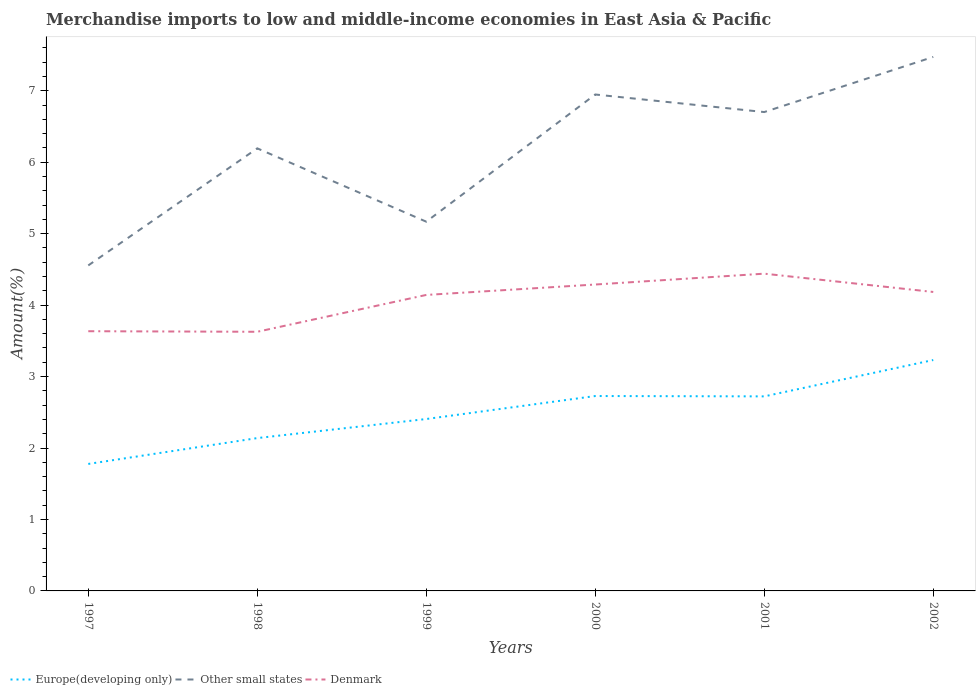How many different coloured lines are there?
Offer a very short reply. 3. Is the number of lines equal to the number of legend labels?
Ensure brevity in your answer.  Yes. Across all years, what is the maximum percentage of amount earned from merchandise imports in Europe(developing only)?
Your answer should be compact. 1.78. What is the total percentage of amount earned from merchandise imports in Europe(developing only) in the graph?
Your answer should be compact. -0.5. What is the difference between the highest and the second highest percentage of amount earned from merchandise imports in Europe(developing only)?
Make the answer very short. 1.45. Is the percentage of amount earned from merchandise imports in Europe(developing only) strictly greater than the percentage of amount earned from merchandise imports in Other small states over the years?
Give a very brief answer. Yes. How many lines are there?
Offer a very short reply. 3. How many years are there in the graph?
Provide a short and direct response. 6. Where does the legend appear in the graph?
Give a very brief answer. Bottom left. How are the legend labels stacked?
Provide a succinct answer. Horizontal. What is the title of the graph?
Offer a terse response. Merchandise imports to low and middle-income economies in East Asia & Pacific. Does "Macao" appear as one of the legend labels in the graph?
Keep it short and to the point. No. What is the label or title of the X-axis?
Your answer should be compact. Years. What is the label or title of the Y-axis?
Your answer should be very brief. Amount(%). What is the Amount(%) of Europe(developing only) in 1997?
Make the answer very short. 1.78. What is the Amount(%) of Other small states in 1997?
Your response must be concise. 4.56. What is the Amount(%) of Denmark in 1997?
Provide a succinct answer. 3.63. What is the Amount(%) in Europe(developing only) in 1998?
Provide a short and direct response. 2.14. What is the Amount(%) in Other small states in 1998?
Ensure brevity in your answer.  6.19. What is the Amount(%) of Denmark in 1998?
Keep it short and to the point. 3.63. What is the Amount(%) in Europe(developing only) in 1999?
Keep it short and to the point. 2.41. What is the Amount(%) in Other small states in 1999?
Keep it short and to the point. 5.17. What is the Amount(%) in Denmark in 1999?
Give a very brief answer. 4.14. What is the Amount(%) in Europe(developing only) in 2000?
Offer a very short reply. 2.73. What is the Amount(%) of Other small states in 2000?
Your response must be concise. 6.95. What is the Amount(%) in Denmark in 2000?
Offer a very short reply. 4.29. What is the Amount(%) of Europe(developing only) in 2001?
Provide a succinct answer. 2.72. What is the Amount(%) in Other small states in 2001?
Provide a succinct answer. 6.7. What is the Amount(%) in Denmark in 2001?
Provide a short and direct response. 4.44. What is the Amount(%) in Europe(developing only) in 2002?
Offer a terse response. 3.23. What is the Amount(%) in Other small states in 2002?
Your answer should be very brief. 7.47. What is the Amount(%) in Denmark in 2002?
Your answer should be very brief. 4.18. Across all years, what is the maximum Amount(%) in Europe(developing only)?
Your answer should be very brief. 3.23. Across all years, what is the maximum Amount(%) of Other small states?
Provide a succinct answer. 7.47. Across all years, what is the maximum Amount(%) in Denmark?
Make the answer very short. 4.44. Across all years, what is the minimum Amount(%) of Europe(developing only)?
Your answer should be very brief. 1.78. Across all years, what is the minimum Amount(%) in Other small states?
Provide a short and direct response. 4.56. Across all years, what is the minimum Amount(%) in Denmark?
Your answer should be very brief. 3.63. What is the total Amount(%) of Europe(developing only) in the graph?
Make the answer very short. 15. What is the total Amount(%) of Other small states in the graph?
Offer a very short reply. 37.04. What is the total Amount(%) in Denmark in the graph?
Make the answer very short. 24.32. What is the difference between the Amount(%) of Europe(developing only) in 1997 and that in 1998?
Provide a succinct answer. -0.36. What is the difference between the Amount(%) in Other small states in 1997 and that in 1998?
Provide a succinct answer. -1.64. What is the difference between the Amount(%) of Denmark in 1997 and that in 1998?
Make the answer very short. 0.01. What is the difference between the Amount(%) of Europe(developing only) in 1997 and that in 1999?
Make the answer very short. -0.63. What is the difference between the Amount(%) of Other small states in 1997 and that in 1999?
Make the answer very short. -0.61. What is the difference between the Amount(%) of Denmark in 1997 and that in 1999?
Provide a short and direct response. -0.51. What is the difference between the Amount(%) in Europe(developing only) in 1997 and that in 2000?
Keep it short and to the point. -0.95. What is the difference between the Amount(%) in Other small states in 1997 and that in 2000?
Your response must be concise. -2.39. What is the difference between the Amount(%) of Denmark in 1997 and that in 2000?
Provide a short and direct response. -0.65. What is the difference between the Amount(%) of Europe(developing only) in 1997 and that in 2001?
Provide a succinct answer. -0.95. What is the difference between the Amount(%) in Other small states in 1997 and that in 2001?
Keep it short and to the point. -2.15. What is the difference between the Amount(%) in Denmark in 1997 and that in 2001?
Ensure brevity in your answer.  -0.81. What is the difference between the Amount(%) in Europe(developing only) in 1997 and that in 2002?
Your answer should be very brief. -1.45. What is the difference between the Amount(%) in Other small states in 1997 and that in 2002?
Offer a terse response. -2.92. What is the difference between the Amount(%) of Denmark in 1997 and that in 2002?
Your answer should be compact. -0.55. What is the difference between the Amount(%) in Europe(developing only) in 1998 and that in 1999?
Your answer should be very brief. -0.27. What is the difference between the Amount(%) of Other small states in 1998 and that in 1999?
Keep it short and to the point. 1.03. What is the difference between the Amount(%) of Denmark in 1998 and that in 1999?
Offer a terse response. -0.52. What is the difference between the Amount(%) of Europe(developing only) in 1998 and that in 2000?
Provide a short and direct response. -0.59. What is the difference between the Amount(%) of Other small states in 1998 and that in 2000?
Your response must be concise. -0.75. What is the difference between the Amount(%) of Denmark in 1998 and that in 2000?
Your answer should be very brief. -0.66. What is the difference between the Amount(%) in Europe(developing only) in 1998 and that in 2001?
Provide a short and direct response. -0.58. What is the difference between the Amount(%) of Other small states in 1998 and that in 2001?
Offer a very short reply. -0.51. What is the difference between the Amount(%) in Denmark in 1998 and that in 2001?
Your response must be concise. -0.81. What is the difference between the Amount(%) in Europe(developing only) in 1998 and that in 2002?
Provide a succinct answer. -1.09. What is the difference between the Amount(%) of Other small states in 1998 and that in 2002?
Offer a very short reply. -1.28. What is the difference between the Amount(%) in Denmark in 1998 and that in 2002?
Provide a succinct answer. -0.56. What is the difference between the Amount(%) in Europe(developing only) in 1999 and that in 2000?
Your response must be concise. -0.32. What is the difference between the Amount(%) in Other small states in 1999 and that in 2000?
Keep it short and to the point. -1.78. What is the difference between the Amount(%) of Denmark in 1999 and that in 2000?
Your response must be concise. -0.15. What is the difference between the Amount(%) in Europe(developing only) in 1999 and that in 2001?
Your answer should be compact. -0.32. What is the difference between the Amount(%) of Other small states in 1999 and that in 2001?
Offer a very short reply. -1.53. What is the difference between the Amount(%) of Denmark in 1999 and that in 2001?
Give a very brief answer. -0.3. What is the difference between the Amount(%) in Europe(developing only) in 1999 and that in 2002?
Offer a terse response. -0.83. What is the difference between the Amount(%) of Other small states in 1999 and that in 2002?
Ensure brevity in your answer.  -2.31. What is the difference between the Amount(%) of Denmark in 1999 and that in 2002?
Your answer should be compact. -0.04. What is the difference between the Amount(%) in Europe(developing only) in 2000 and that in 2001?
Offer a very short reply. 0.01. What is the difference between the Amount(%) of Other small states in 2000 and that in 2001?
Your answer should be compact. 0.25. What is the difference between the Amount(%) of Denmark in 2000 and that in 2001?
Keep it short and to the point. -0.15. What is the difference between the Amount(%) of Europe(developing only) in 2000 and that in 2002?
Your response must be concise. -0.5. What is the difference between the Amount(%) of Other small states in 2000 and that in 2002?
Offer a very short reply. -0.53. What is the difference between the Amount(%) in Denmark in 2000 and that in 2002?
Offer a very short reply. 0.1. What is the difference between the Amount(%) of Europe(developing only) in 2001 and that in 2002?
Your answer should be compact. -0.51. What is the difference between the Amount(%) in Other small states in 2001 and that in 2002?
Keep it short and to the point. -0.77. What is the difference between the Amount(%) of Denmark in 2001 and that in 2002?
Provide a short and direct response. 0.26. What is the difference between the Amount(%) of Europe(developing only) in 1997 and the Amount(%) of Other small states in 1998?
Your answer should be very brief. -4.42. What is the difference between the Amount(%) in Europe(developing only) in 1997 and the Amount(%) in Denmark in 1998?
Your answer should be compact. -1.85. What is the difference between the Amount(%) in Europe(developing only) in 1997 and the Amount(%) in Other small states in 1999?
Offer a terse response. -3.39. What is the difference between the Amount(%) in Europe(developing only) in 1997 and the Amount(%) in Denmark in 1999?
Your answer should be compact. -2.37. What is the difference between the Amount(%) in Other small states in 1997 and the Amount(%) in Denmark in 1999?
Offer a very short reply. 0.41. What is the difference between the Amount(%) of Europe(developing only) in 1997 and the Amount(%) of Other small states in 2000?
Provide a succinct answer. -5.17. What is the difference between the Amount(%) of Europe(developing only) in 1997 and the Amount(%) of Denmark in 2000?
Keep it short and to the point. -2.51. What is the difference between the Amount(%) in Other small states in 1997 and the Amount(%) in Denmark in 2000?
Ensure brevity in your answer.  0.27. What is the difference between the Amount(%) of Europe(developing only) in 1997 and the Amount(%) of Other small states in 2001?
Offer a terse response. -4.92. What is the difference between the Amount(%) in Europe(developing only) in 1997 and the Amount(%) in Denmark in 2001?
Your answer should be compact. -2.66. What is the difference between the Amount(%) of Other small states in 1997 and the Amount(%) of Denmark in 2001?
Your response must be concise. 0.12. What is the difference between the Amount(%) in Europe(developing only) in 1997 and the Amount(%) in Other small states in 2002?
Offer a very short reply. -5.7. What is the difference between the Amount(%) of Europe(developing only) in 1997 and the Amount(%) of Denmark in 2002?
Keep it short and to the point. -2.41. What is the difference between the Amount(%) in Other small states in 1997 and the Amount(%) in Denmark in 2002?
Keep it short and to the point. 0.37. What is the difference between the Amount(%) in Europe(developing only) in 1998 and the Amount(%) in Other small states in 1999?
Offer a very short reply. -3.03. What is the difference between the Amount(%) in Europe(developing only) in 1998 and the Amount(%) in Denmark in 1999?
Provide a short and direct response. -2. What is the difference between the Amount(%) in Other small states in 1998 and the Amount(%) in Denmark in 1999?
Ensure brevity in your answer.  2.05. What is the difference between the Amount(%) in Europe(developing only) in 1998 and the Amount(%) in Other small states in 2000?
Ensure brevity in your answer.  -4.81. What is the difference between the Amount(%) of Europe(developing only) in 1998 and the Amount(%) of Denmark in 2000?
Your answer should be compact. -2.15. What is the difference between the Amount(%) of Other small states in 1998 and the Amount(%) of Denmark in 2000?
Provide a succinct answer. 1.91. What is the difference between the Amount(%) in Europe(developing only) in 1998 and the Amount(%) in Other small states in 2001?
Provide a succinct answer. -4.56. What is the difference between the Amount(%) in Europe(developing only) in 1998 and the Amount(%) in Denmark in 2001?
Provide a short and direct response. -2.3. What is the difference between the Amount(%) of Other small states in 1998 and the Amount(%) of Denmark in 2001?
Provide a short and direct response. 1.75. What is the difference between the Amount(%) of Europe(developing only) in 1998 and the Amount(%) of Other small states in 2002?
Your response must be concise. -5.33. What is the difference between the Amount(%) of Europe(developing only) in 1998 and the Amount(%) of Denmark in 2002?
Ensure brevity in your answer.  -2.05. What is the difference between the Amount(%) in Other small states in 1998 and the Amount(%) in Denmark in 2002?
Keep it short and to the point. 2.01. What is the difference between the Amount(%) of Europe(developing only) in 1999 and the Amount(%) of Other small states in 2000?
Provide a succinct answer. -4.54. What is the difference between the Amount(%) in Europe(developing only) in 1999 and the Amount(%) in Denmark in 2000?
Your response must be concise. -1.88. What is the difference between the Amount(%) in Other small states in 1999 and the Amount(%) in Denmark in 2000?
Your response must be concise. 0.88. What is the difference between the Amount(%) of Europe(developing only) in 1999 and the Amount(%) of Other small states in 2001?
Your answer should be compact. -4.3. What is the difference between the Amount(%) of Europe(developing only) in 1999 and the Amount(%) of Denmark in 2001?
Make the answer very short. -2.03. What is the difference between the Amount(%) of Other small states in 1999 and the Amount(%) of Denmark in 2001?
Give a very brief answer. 0.73. What is the difference between the Amount(%) in Europe(developing only) in 1999 and the Amount(%) in Other small states in 2002?
Make the answer very short. -5.07. What is the difference between the Amount(%) of Europe(developing only) in 1999 and the Amount(%) of Denmark in 2002?
Keep it short and to the point. -1.78. What is the difference between the Amount(%) in Other small states in 1999 and the Amount(%) in Denmark in 2002?
Provide a short and direct response. 0.98. What is the difference between the Amount(%) of Europe(developing only) in 2000 and the Amount(%) of Other small states in 2001?
Provide a succinct answer. -3.97. What is the difference between the Amount(%) of Europe(developing only) in 2000 and the Amount(%) of Denmark in 2001?
Offer a terse response. -1.71. What is the difference between the Amount(%) in Other small states in 2000 and the Amount(%) in Denmark in 2001?
Give a very brief answer. 2.51. What is the difference between the Amount(%) in Europe(developing only) in 2000 and the Amount(%) in Other small states in 2002?
Provide a succinct answer. -4.75. What is the difference between the Amount(%) in Europe(developing only) in 2000 and the Amount(%) in Denmark in 2002?
Provide a succinct answer. -1.46. What is the difference between the Amount(%) of Other small states in 2000 and the Amount(%) of Denmark in 2002?
Your response must be concise. 2.76. What is the difference between the Amount(%) of Europe(developing only) in 2001 and the Amount(%) of Other small states in 2002?
Your answer should be very brief. -4.75. What is the difference between the Amount(%) in Europe(developing only) in 2001 and the Amount(%) in Denmark in 2002?
Ensure brevity in your answer.  -1.46. What is the difference between the Amount(%) in Other small states in 2001 and the Amount(%) in Denmark in 2002?
Provide a succinct answer. 2.52. What is the average Amount(%) in Europe(developing only) per year?
Your answer should be very brief. 2.5. What is the average Amount(%) of Other small states per year?
Your response must be concise. 6.17. What is the average Amount(%) of Denmark per year?
Your response must be concise. 4.05. In the year 1997, what is the difference between the Amount(%) in Europe(developing only) and Amount(%) in Other small states?
Give a very brief answer. -2.78. In the year 1997, what is the difference between the Amount(%) of Europe(developing only) and Amount(%) of Denmark?
Ensure brevity in your answer.  -1.86. In the year 1997, what is the difference between the Amount(%) of Other small states and Amount(%) of Denmark?
Ensure brevity in your answer.  0.92. In the year 1998, what is the difference between the Amount(%) in Europe(developing only) and Amount(%) in Other small states?
Your answer should be compact. -4.06. In the year 1998, what is the difference between the Amount(%) in Europe(developing only) and Amount(%) in Denmark?
Provide a succinct answer. -1.49. In the year 1998, what is the difference between the Amount(%) of Other small states and Amount(%) of Denmark?
Give a very brief answer. 2.57. In the year 1999, what is the difference between the Amount(%) in Europe(developing only) and Amount(%) in Other small states?
Ensure brevity in your answer.  -2.76. In the year 1999, what is the difference between the Amount(%) of Europe(developing only) and Amount(%) of Denmark?
Keep it short and to the point. -1.74. In the year 1999, what is the difference between the Amount(%) of Other small states and Amount(%) of Denmark?
Offer a very short reply. 1.03. In the year 2000, what is the difference between the Amount(%) in Europe(developing only) and Amount(%) in Other small states?
Keep it short and to the point. -4.22. In the year 2000, what is the difference between the Amount(%) in Europe(developing only) and Amount(%) in Denmark?
Make the answer very short. -1.56. In the year 2000, what is the difference between the Amount(%) in Other small states and Amount(%) in Denmark?
Ensure brevity in your answer.  2.66. In the year 2001, what is the difference between the Amount(%) of Europe(developing only) and Amount(%) of Other small states?
Provide a short and direct response. -3.98. In the year 2001, what is the difference between the Amount(%) in Europe(developing only) and Amount(%) in Denmark?
Provide a short and direct response. -1.72. In the year 2001, what is the difference between the Amount(%) in Other small states and Amount(%) in Denmark?
Provide a succinct answer. 2.26. In the year 2002, what is the difference between the Amount(%) in Europe(developing only) and Amount(%) in Other small states?
Give a very brief answer. -4.24. In the year 2002, what is the difference between the Amount(%) in Europe(developing only) and Amount(%) in Denmark?
Your answer should be compact. -0.95. In the year 2002, what is the difference between the Amount(%) of Other small states and Amount(%) of Denmark?
Your answer should be very brief. 3.29. What is the ratio of the Amount(%) in Europe(developing only) in 1997 to that in 1998?
Offer a very short reply. 0.83. What is the ratio of the Amount(%) of Other small states in 1997 to that in 1998?
Give a very brief answer. 0.74. What is the ratio of the Amount(%) of Europe(developing only) in 1997 to that in 1999?
Give a very brief answer. 0.74. What is the ratio of the Amount(%) of Other small states in 1997 to that in 1999?
Offer a very short reply. 0.88. What is the ratio of the Amount(%) in Denmark in 1997 to that in 1999?
Your answer should be very brief. 0.88. What is the ratio of the Amount(%) in Europe(developing only) in 1997 to that in 2000?
Offer a very short reply. 0.65. What is the ratio of the Amount(%) in Other small states in 1997 to that in 2000?
Your answer should be compact. 0.66. What is the ratio of the Amount(%) of Denmark in 1997 to that in 2000?
Ensure brevity in your answer.  0.85. What is the ratio of the Amount(%) in Europe(developing only) in 1997 to that in 2001?
Provide a succinct answer. 0.65. What is the ratio of the Amount(%) of Other small states in 1997 to that in 2001?
Ensure brevity in your answer.  0.68. What is the ratio of the Amount(%) of Denmark in 1997 to that in 2001?
Provide a succinct answer. 0.82. What is the ratio of the Amount(%) in Europe(developing only) in 1997 to that in 2002?
Ensure brevity in your answer.  0.55. What is the ratio of the Amount(%) in Other small states in 1997 to that in 2002?
Ensure brevity in your answer.  0.61. What is the ratio of the Amount(%) of Denmark in 1997 to that in 2002?
Make the answer very short. 0.87. What is the ratio of the Amount(%) in Europe(developing only) in 1998 to that in 1999?
Offer a terse response. 0.89. What is the ratio of the Amount(%) of Other small states in 1998 to that in 1999?
Your answer should be very brief. 1.2. What is the ratio of the Amount(%) of Denmark in 1998 to that in 1999?
Provide a succinct answer. 0.88. What is the ratio of the Amount(%) of Europe(developing only) in 1998 to that in 2000?
Keep it short and to the point. 0.78. What is the ratio of the Amount(%) of Other small states in 1998 to that in 2000?
Provide a succinct answer. 0.89. What is the ratio of the Amount(%) in Denmark in 1998 to that in 2000?
Offer a terse response. 0.85. What is the ratio of the Amount(%) in Europe(developing only) in 1998 to that in 2001?
Your answer should be very brief. 0.79. What is the ratio of the Amount(%) of Other small states in 1998 to that in 2001?
Your response must be concise. 0.92. What is the ratio of the Amount(%) of Denmark in 1998 to that in 2001?
Your answer should be very brief. 0.82. What is the ratio of the Amount(%) of Europe(developing only) in 1998 to that in 2002?
Provide a short and direct response. 0.66. What is the ratio of the Amount(%) of Other small states in 1998 to that in 2002?
Provide a short and direct response. 0.83. What is the ratio of the Amount(%) in Denmark in 1998 to that in 2002?
Your answer should be very brief. 0.87. What is the ratio of the Amount(%) of Europe(developing only) in 1999 to that in 2000?
Your response must be concise. 0.88. What is the ratio of the Amount(%) in Other small states in 1999 to that in 2000?
Offer a terse response. 0.74. What is the ratio of the Amount(%) of Denmark in 1999 to that in 2000?
Give a very brief answer. 0.97. What is the ratio of the Amount(%) in Europe(developing only) in 1999 to that in 2001?
Keep it short and to the point. 0.88. What is the ratio of the Amount(%) in Other small states in 1999 to that in 2001?
Your answer should be very brief. 0.77. What is the ratio of the Amount(%) in Denmark in 1999 to that in 2001?
Your answer should be compact. 0.93. What is the ratio of the Amount(%) in Europe(developing only) in 1999 to that in 2002?
Ensure brevity in your answer.  0.74. What is the ratio of the Amount(%) in Other small states in 1999 to that in 2002?
Give a very brief answer. 0.69. What is the ratio of the Amount(%) of Europe(developing only) in 2000 to that in 2001?
Make the answer very short. 1. What is the ratio of the Amount(%) in Other small states in 2000 to that in 2001?
Your answer should be compact. 1.04. What is the ratio of the Amount(%) of Denmark in 2000 to that in 2001?
Offer a terse response. 0.97. What is the ratio of the Amount(%) of Europe(developing only) in 2000 to that in 2002?
Your answer should be compact. 0.84. What is the ratio of the Amount(%) of Other small states in 2000 to that in 2002?
Offer a terse response. 0.93. What is the ratio of the Amount(%) of Denmark in 2000 to that in 2002?
Provide a short and direct response. 1.02. What is the ratio of the Amount(%) in Europe(developing only) in 2001 to that in 2002?
Your response must be concise. 0.84. What is the ratio of the Amount(%) in Other small states in 2001 to that in 2002?
Ensure brevity in your answer.  0.9. What is the ratio of the Amount(%) of Denmark in 2001 to that in 2002?
Your answer should be compact. 1.06. What is the difference between the highest and the second highest Amount(%) of Europe(developing only)?
Ensure brevity in your answer.  0.5. What is the difference between the highest and the second highest Amount(%) of Other small states?
Give a very brief answer. 0.53. What is the difference between the highest and the second highest Amount(%) of Denmark?
Make the answer very short. 0.15. What is the difference between the highest and the lowest Amount(%) in Europe(developing only)?
Offer a very short reply. 1.45. What is the difference between the highest and the lowest Amount(%) in Other small states?
Give a very brief answer. 2.92. What is the difference between the highest and the lowest Amount(%) in Denmark?
Your answer should be compact. 0.81. 